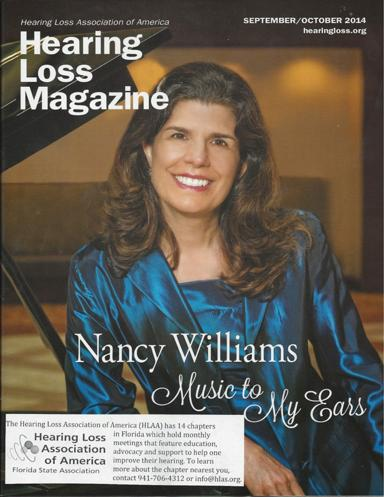What is the name of the magazine mentioned in the image?
 The name of the magazine is Hearing Loss Magazine. What organization is associated with the magazine? The Hearing Loss Association of America (HLAA) is associated with the magazine. What do the monthly meetings of the HLAA chapters feature? The monthly meetings of the HLAA chapters feature education and support for people looking to improve their hearing. How can one get more information about a chapter nearest to their location? To get more information about the chapter nearest to your location, you can contact 941-706-4312 or email info@hlas.org. Who is Nancy Williams and what is her connection to the magazine? Nancy Williams is featured in the magazine and is likely an author or a personality involved in hearing loss awareness, music, or a related topic. 